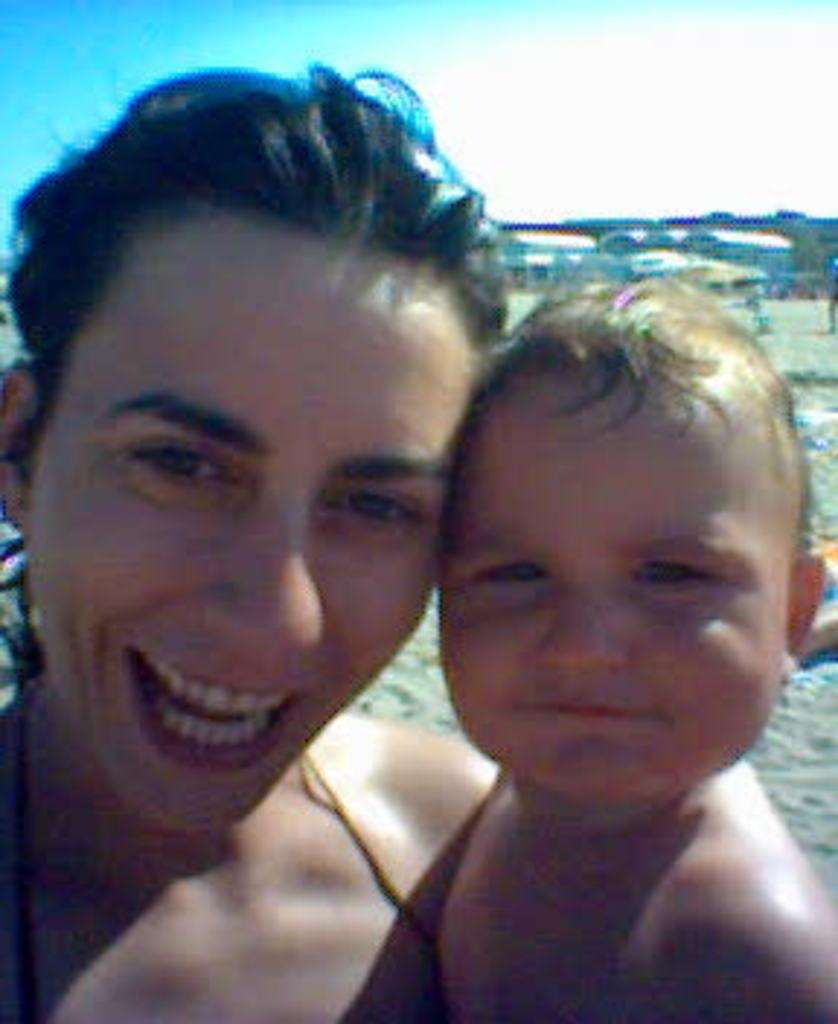Who is the main subject in the image? There is a woman in the image. What is the woman doing in the image? The woman is holding a baby. What can be seen in the background of the image? There are buildings in the background of the image. What object is present to provide shade or protection from the weather? There is an umbrella in the image. How would you describe the sky in the image? The sky is blue and cloudy. Can you identify any other human in the image? Yes, there is a human on the ground in the image. What type of prose can be heard being read to the baby in the image? There is no indication in the image that any prose is being read to the baby. What type of bag is the woman carrying in the image? There is no bag visible in the image. 